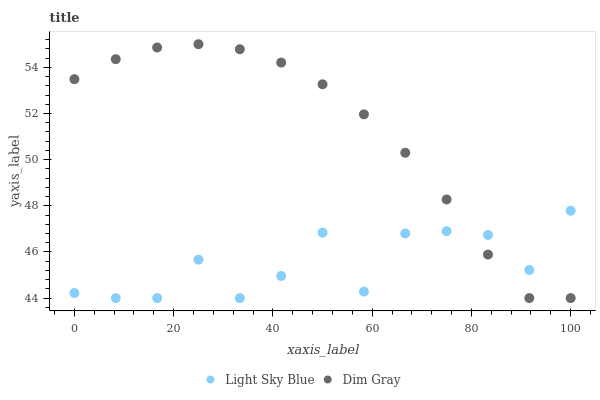Does Light Sky Blue have the minimum area under the curve?
Answer yes or no. Yes. Does Dim Gray have the maximum area under the curve?
Answer yes or no. Yes. Does Light Sky Blue have the maximum area under the curve?
Answer yes or no. No. Is Dim Gray the smoothest?
Answer yes or no. Yes. Is Light Sky Blue the roughest?
Answer yes or no. Yes. Is Light Sky Blue the smoothest?
Answer yes or no. No. Does Dim Gray have the lowest value?
Answer yes or no. Yes. Does Dim Gray have the highest value?
Answer yes or no. Yes. Does Light Sky Blue have the highest value?
Answer yes or no. No. Does Dim Gray intersect Light Sky Blue?
Answer yes or no. Yes. Is Dim Gray less than Light Sky Blue?
Answer yes or no. No. Is Dim Gray greater than Light Sky Blue?
Answer yes or no. No. 